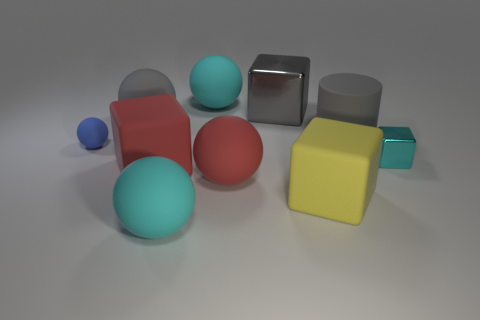How big is the gray metallic thing?
Your answer should be compact. Large. The matte cube that is the same size as the yellow rubber object is what color?
Make the answer very short. Red. Is there a large object of the same color as the tiny metal cube?
Provide a succinct answer. Yes. What is the small cyan thing made of?
Provide a short and direct response. Metal. What number of tiny blue objects are there?
Your response must be concise. 1. There is a shiny block that is to the left of the small cyan shiny cube; is it the same color as the matte block that is on the left side of the big yellow object?
Make the answer very short. No. What size is the sphere that is the same color as the large metal thing?
Provide a short and direct response. Large. How many other things are the same size as the cyan block?
Offer a very short reply. 1. The object that is in front of the large yellow rubber thing is what color?
Provide a succinct answer. Cyan. Do the cyan object that is behind the large gray ball and the large gray block have the same material?
Offer a very short reply. No. 